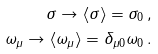Convert formula to latex. <formula><loc_0><loc_0><loc_500><loc_500>\sigma \rightarrow \langle \sigma \rangle = \sigma _ { 0 } \, , \\ \omega _ { \mu } \rightarrow \langle \omega _ { \mu } \rangle = \delta _ { \mu 0 } \omega _ { 0 } \, .</formula> 